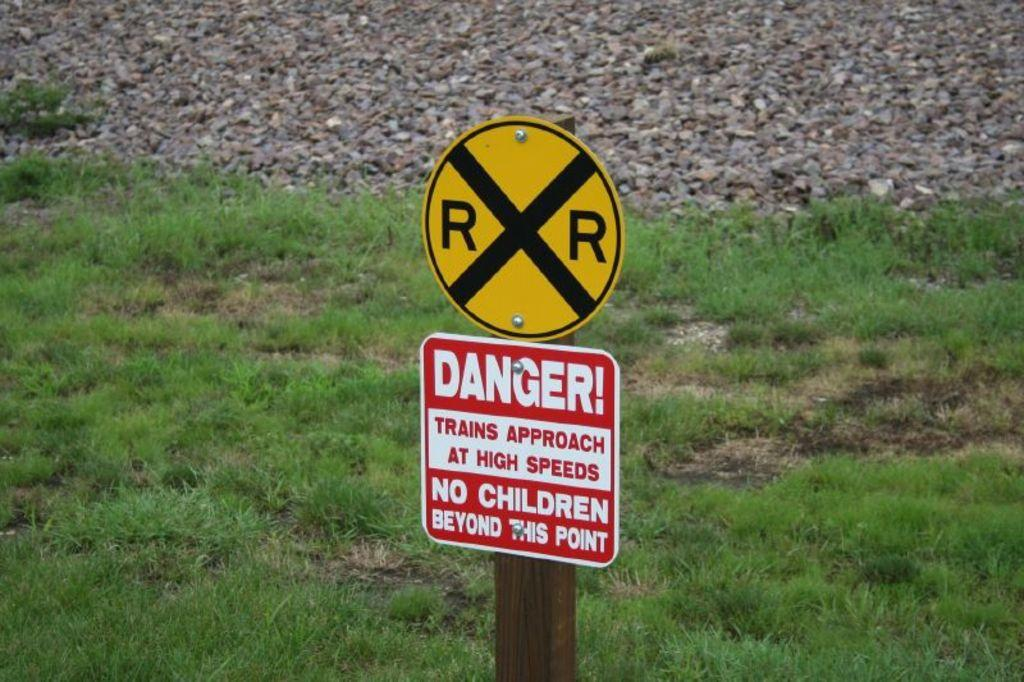<image>
Render a clear and concise summary of the photo. A warning sign about high speed trains in the area. 